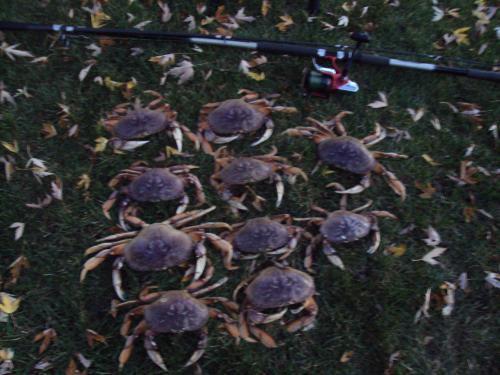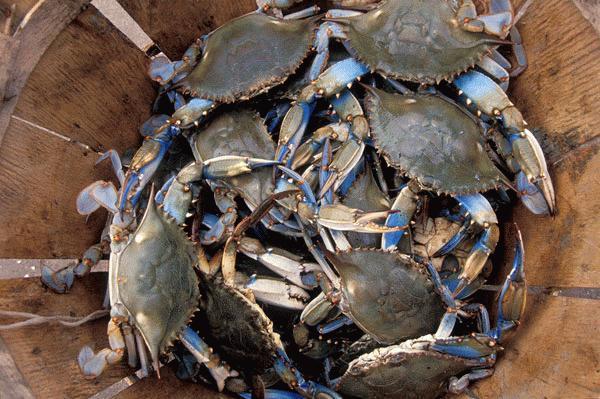The first image is the image on the left, the second image is the image on the right. Evaluate the accuracy of this statement regarding the images: "One image contains at least one human hand, and the other image includes some crabs and a box formed of a grid of box shapes.". Is it true? Answer yes or no. No. The first image is the image on the left, the second image is the image on the right. Assess this claim about the two images: "A person is holding up a set of crabs in one of the images.". Correct or not? Answer yes or no. No. 